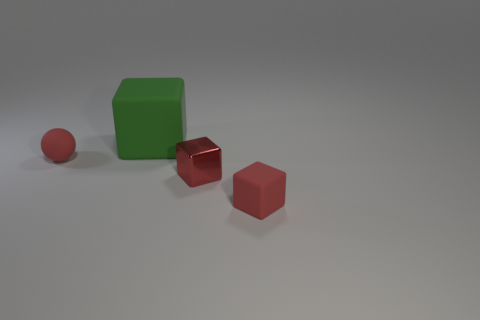There is another cube that is the same size as the red matte cube; what material is it? metal 